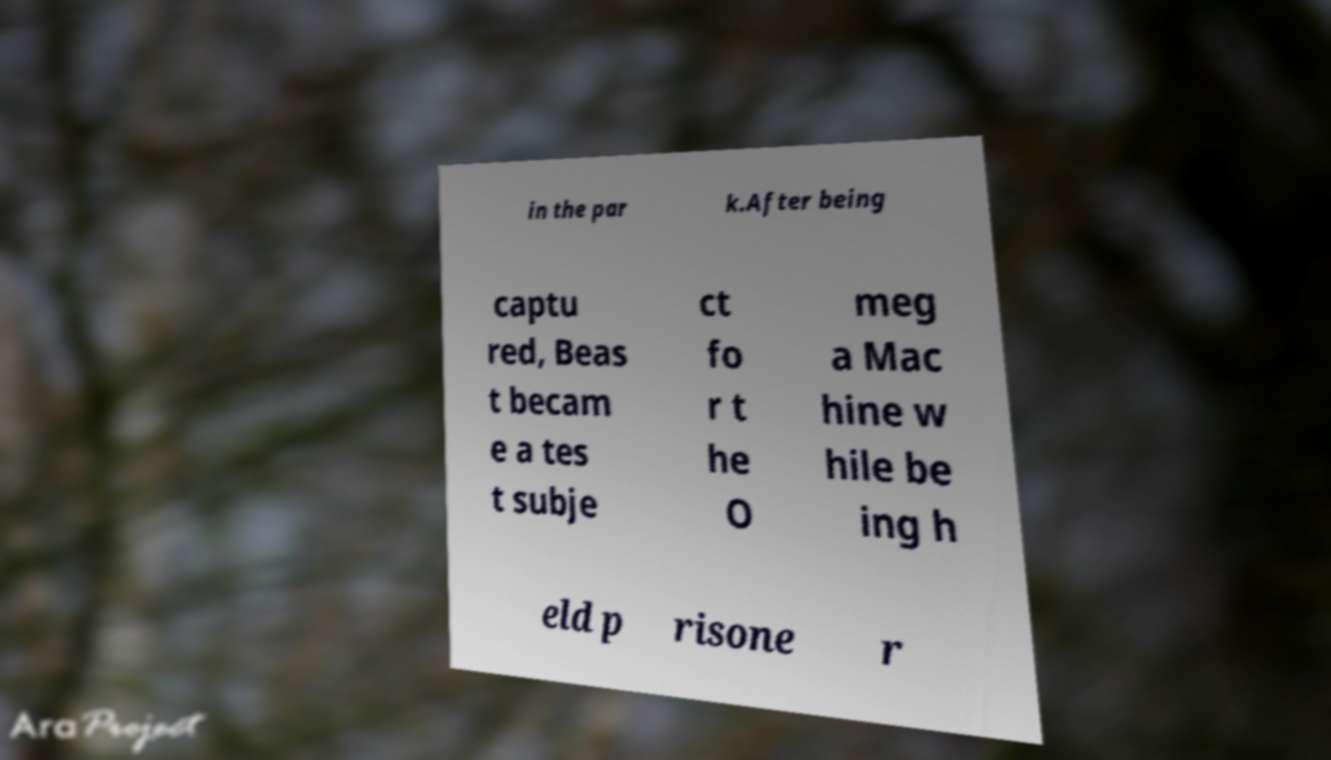Please read and relay the text visible in this image. What does it say? in the par k.After being captu red, Beas t becam e a tes t subje ct fo r t he O meg a Mac hine w hile be ing h eld p risone r 